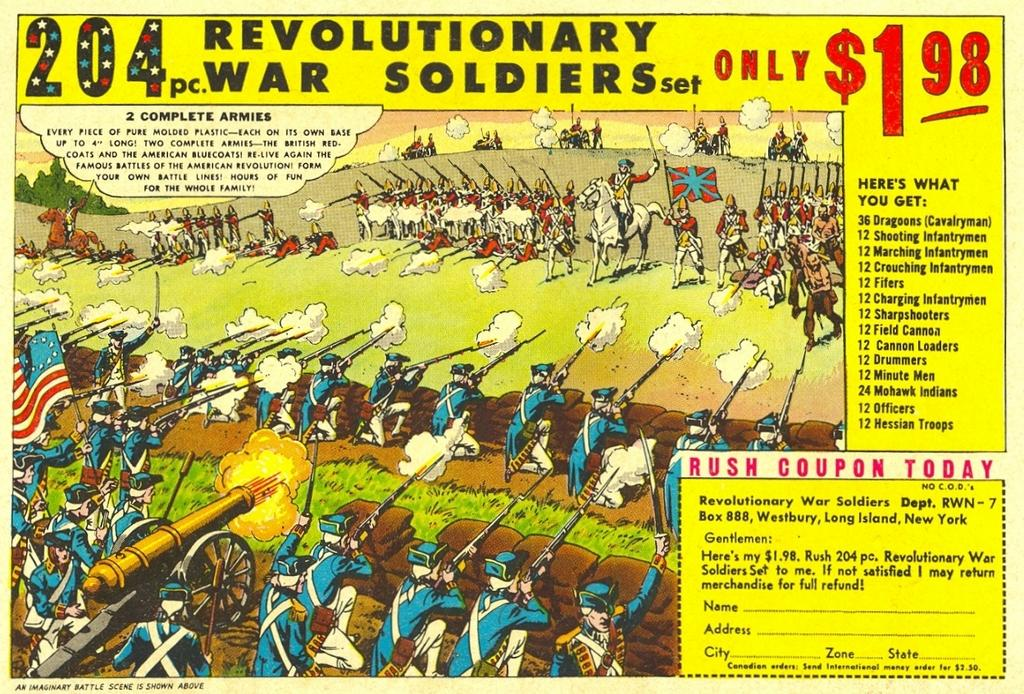Provide a one-sentence caption for the provided image. A picture of soldiers firing guns advertising Revolutionary War Soldiers set for only $1.98. 